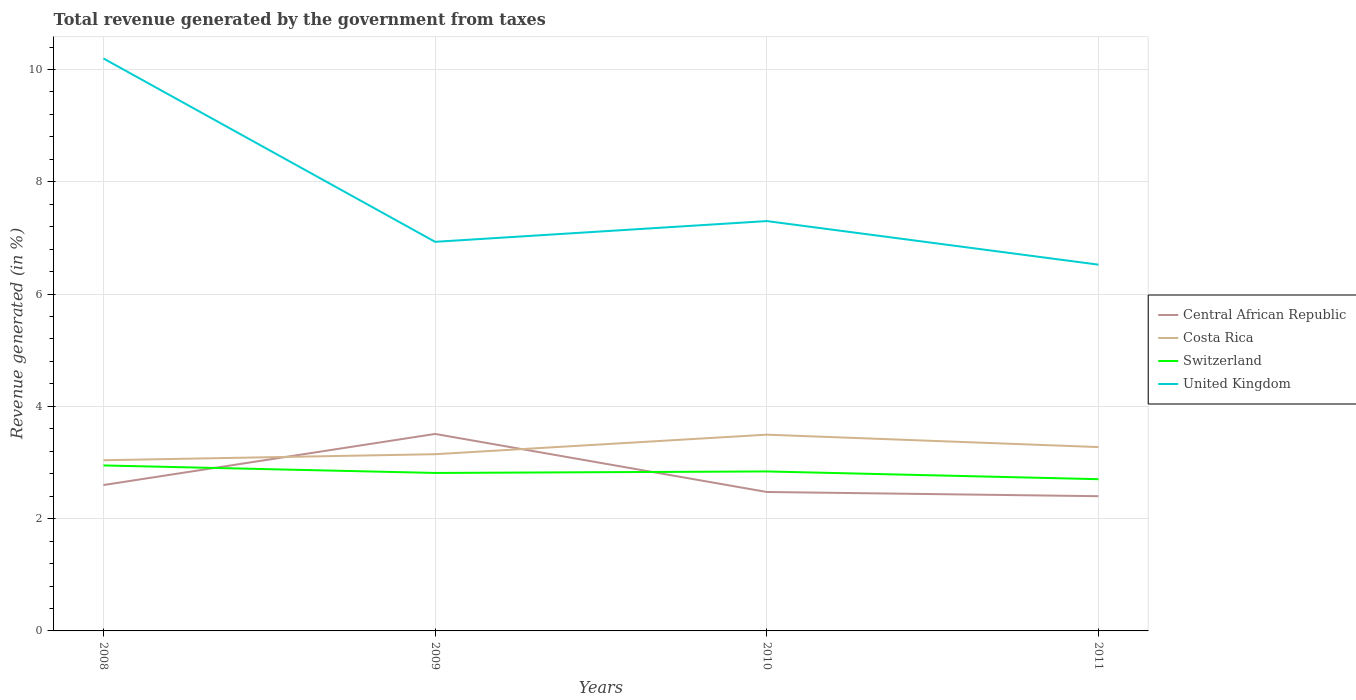Across all years, what is the maximum total revenue generated in United Kingdom?
Ensure brevity in your answer.  6.52. What is the total total revenue generated in Central African Republic in the graph?
Your response must be concise. 0.12. What is the difference between the highest and the second highest total revenue generated in Central African Republic?
Provide a short and direct response. 1.11. Is the total revenue generated in Central African Republic strictly greater than the total revenue generated in Costa Rica over the years?
Give a very brief answer. No. What is the difference between two consecutive major ticks on the Y-axis?
Your answer should be compact. 2. Are the values on the major ticks of Y-axis written in scientific E-notation?
Your answer should be compact. No. Does the graph contain any zero values?
Provide a short and direct response. No. What is the title of the graph?
Offer a terse response. Total revenue generated by the government from taxes. Does "Fiji" appear as one of the legend labels in the graph?
Your answer should be compact. No. What is the label or title of the X-axis?
Provide a short and direct response. Years. What is the label or title of the Y-axis?
Ensure brevity in your answer.  Revenue generated (in %). What is the Revenue generated (in %) in Central African Republic in 2008?
Ensure brevity in your answer.  2.6. What is the Revenue generated (in %) of Costa Rica in 2008?
Ensure brevity in your answer.  3.04. What is the Revenue generated (in %) of Switzerland in 2008?
Your response must be concise. 2.95. What is the Revenue generated (in %) in United Kingdom in 2008?
Ensure brevity in your answer.  10.2. What is the Revenue generated (in %) of Central African Republic in 2009?
Your response must be concise. 3.51. What is the Revenue generated (in %) in Costa Rica in 2009?
Offer a very short reply. 3.15. What is the Revenue generated (in %) of Switzerland in 2009?
Provide a short and direct response. 2.81. What is the Revenue generated (in %) in United Kingdom in 2009?
Provide a succinct answer. 6.93. What is the Revenue generated (in %) in Central African Republic in 2010?
Make the answer very short. 2.47. What is the Revenue generated (in %) of Costa Rica in 2010?
Offer a very short reply. 3.5. What is the Revenue generated (in %) of Switzerland in 2010?
Provide a succinct answer. 2.84. What is the Revenue generated (in %) of United Kingdom in 2010?
Your answer should be very brief. 7.3. What is the Revenue generated (in %) in Central African Republic in 2011?
Make the answer very short. 2.4. What is the Revenue generated (in %) in Costa Rica in 2011?
Offer a very short reply. 3.27. What is the Revenue generated (in %) of Switzerland in 2011?
Your answer should be very brief. 2.7. What is the Revenue generated (in %) in United Kingdom in 2011?
Give a very brief answer. 6.52. Across all years, what is the maximum Revenue generated (in %) in Central African Republic?
Provide a short and direct response. 3.51. Across all years, what is the maximum Revenue generated (in %) in Costa Rica?
Your response must be concise. 3.5. Across all years, what is the maximum Revenue generated (in %) of Switzerland?
Make the answer very short. 2.95. Across all years, what is the maximum Revenue generated (in %) in United Kingdom?
Your response must be concise. 10.2. Across all years, what is the minimum Revenue generated (in %) of Central African Republic?
Offer a terse response. 2.4. Across all years, what is the minimum Revenue generated (in %) in Costa Rica?
Keep it short and to the point. 3.04. Across all years, what is the minimum Revenue generated (in %) of Switzerland?
Ensure brevity in your answer.  2.7. Across all years, what is the minimum Revenue generated (in %) of United Kingdom?
Provide a short and direct response. 6.52. What is the total Revenue generated (in %) of Central African Republic in the graph?
Make the answer very short. 10.98. What is the total Revenue generated (in %) in Costa Rica in the graph?
Your answer should be compact. 12.96. What is the total Revenue generated (in %) of Switzerland in the graph?
Give a very brief answer. 11.31. What is the total Revenue generated (in %) of United Kingdom in the graph?
Provide a short and direct response. 30.95. What is the difference between the Revenue generated (in %) in Central African Republic in 2008 and that in 2009?
Ensure brevity in your answer.  -0.91. What is the difference between the Revenue generated (in %) of Costa Rica in 2008 and that in 2009?
Ensure brevity in your answer.  -0.11. What is the difference between the Revenue generated (in %) of Switzerland in 2008 and that in 2009?
Offer a terse response. 0.13. What is the difference between the Revenue generated (in %) in United Kingdom in 2008 and that in 2009?
Your answer should be very brief. 3.27. What is the difference between the Revenue generated (in %) of Central African Republic in 2008 and that in 2010?
Make the answer very short. 0.12. What is the difference between the Revenue generated (in %) in Costa Rica in 2008 and that in 2010?
Ensure brevity in your answer.  -0.46. What is the difference between the Revenue generated (in %) in Switzerland in 2008 and that in 2010?
Offer a very short reply. 0.11. What is the difference between the Revenue generated (in %) in United Kingdom in 2008 and that in 2010?
Make the answer very short. 2.9. What is the difference between the Revenue generated (in %) in Central African Republic in 2008 and that in 2011?
Ensure brevity in your answer.  0.2. What is the difference between the Revenue generated (in %) in Costa Rica in 2008 and that in 2011?
Your response must be concise. -0.23. What is the difference between the Revenue generated (in %) of Switzerland in 2008 and that in 2011?
Offer a very short reply. 0.24. What is the difference between the Revenue generated (in %) in United Kingdom in 2008 and that in 2011?
Provide a short and direct response. 3.67. What is the difference between the Revenue generated (in %) in Central African Republic in 2009 and that in 2010?
Your answer should be compact. 1.03. What is the difference between the Revenue generated (in %) of Costa Rica in 2009 and that in 2010?
Your answer should be very brief. -0.35. What is the difference between the Revenue generated (in %) of Switzerland in 2009 and that in 2010?
Your response must be concise. -0.03. What is the difference between the Revenue generated (in %) of United Kingdom in 2009 and that in 2010?
Ensure brevity in your answer.  -0.37. What is the difference between the Revenue generated (in %) of Central African Republic in 2009 and that in 2011?
Your response must be concise. 1.11. What is the difference between the Revenue generated (in %) in Costa Rica in 2009 and that in 2011?
Keep it short and to the point. -0.13. What is the difference between the Revenue generated (in %) in United Kingdom in 2009 and that in 2011?
Your answer should be compact. 0.41. What is the difference between the Revenue generated (in %) of Central African Republic in 2010 and that in 2011?
Provide a succinct answer. 0.07. What is the difference between the Revenue generated (in %) in Costa Rica in 2010 and that in 2011?
Provide a succinct answer. 0.22. What is the difference between the Revenue generated (in %) of Switzerland in 2010 and that in 2011?
Make the answer very short. 0.14. What is the difference between the Revenue generated (in %) in United Kingdom in 2010 and that in 2011?
Your answer should be very brief. 0.78. What is the difference between the Revenue generated (in %) of Central African Republic in 2008 and the Revenue generated (in %) of Costa Rica in 2009?
Offer a terse response. -0.55. What is the difference between the Revenue generated (in %) of Central African Republic in 2008 and the Revenue generated (in %) of Switzerland in 2009?
Provide a short and direct response. -0.22. What is the difference between the Revenue generated (in %) in Central African Republic in 2008 and the Revenue generated (in %) in United Kingdom in 2009?
Your answer should be very brief. -4.33. What is the difference between the Revenue generated (in %) in Costa Rica in 2008 and the Revenue generated (in %) in Switzerland in 2009?
Provide a succinct answer. 0.23. What is the difference between the Revenue generated (in %) of Costa Rica in 2008 and the Revenue generated (in %) of United Kingdom in 2009?
Keep it short and to the point. -3.89. What is the difference between the Revenue generated (in %) of Switzerland in 2008 and the Revenue generated (in %) of United Kingdom in 2009?
Make the answer very short. -3.98. What is the difference between the Revenue generated (in %) in Central African Republic in 2008 and the Revenue generated (in %) in Costa Rica in 2010?
Provide a succinct answer. -0.9. What is the difference between the Revenue generated (in %) of Central African Republic in 2008 and the Revenue generated (in %) of Switzerland in 2010?
Your answer should be very brief. -0.24. What is the difference between the Revenue generated (in %) in Central African Republic in 2008 and the Revenue generated (in %) in United Kingdom in 2010?
Provide a short and direct response. -4.7. What is the difference between the Revenue generated (in %) of Costa Rica in 2008 and the Revenue generated (in %) of Switzerland in 2010?
Provide a succinct answer. 0.2. What is the difference between the Revenue generated (in %) in Costa Rica in 2008 and the Revenue generated (in %) in United Kingdom in 2010?
Your answer should be compact. -4.26. What is the difference between the Revenue generated (in %) in Switzerland in 2008 and the Revenue generated (in %) in United Kingdom in 2010?
Your answer should be compact. -4.35. What is the difference between the Revenue generated (in %) in Central African Republic in 2008 and the Revenue generated (in %) in Costa Rica in 2011?
Provide a short and direct response. -0.68. What is the difference between the Revenue generated (in %) of Central African Republic in 2008 and the Revenue generated (in %) of Switzerland in 2011?
Offer a terse response. -0.1. What is the difference between the Revenue generated (in %) of Central African Republic in 2008 and the Revenue generated (in %) of United Kingdom in 2011?
Offer a terse response. -3.93. What is the difference between the Revenue generated (in %) of Costa Rica in 2008 and the Revenue generated (in %) of Switzerland in 2011?
Keep it short and to the point. 0.34. What is the difference between the Revenue generated (in %) in Costa Rica in 2008 and the Revenue generated (in %) in United Kingdom in 2011?
Provide a succinct answer. -3.48. What is the difference between the Revenue generated (in %) in Switzerland in 2008 and the Revenue generated (in %) in United Kingdom in 2011?
Keep it short and to the point. -3.58. What is the difference between the Revenue generated (in %) of Central African Republic in 2009 and the Revenue generated (in %) of Costa Rica in 2010?
Ensure brevity in your answer.  0.01. What is the difference between the Revenue generated (in %) in Central African Republic in 2009 and the Revenue generated (in %) in Switzerland in 2010?
Offer a very short reply. 0.67. What is the difference between the Revenue generated (in %) of Central African Republic in 2009 and the Revenue generated (in %) of United Kingdom in 2010?
Your answer should be compact. -3.79. What is the difference between the Revenue generated (in %) in Costa Rica in 2009 and the Revenue generated (in %) in Switzerland in 2010?
Keep it short and to the point. 0.31. What is the difference between the Revenue generated (in %) in Costa Rica in 2009 and the Revenue generated (in %) in United Kingdom in 2010?
Your response must be concise. -4.15. What is the difference between the Revenue generated (in %) in Switzerland in 2009 and the Revenue generated (in %) in United Kingdom in 2010?
Provide a short and direct response. -4.49. What is the difference between the Revenue generated (in %) of Central African Republic in 2009 and the Revenue generated (in %) of Costa Rica in 2011?
Your answer should be very brief. 0.23. What is the difference between the Revenue generated (in %) in Central African Republic in 2009 and the Revenue generated (in %) in Switzerland in 2011?
Make the answer very short. 0.81. What is the difference between the Revenue generated (in %) of Central African Republic in 2009 and the Revenue generated (in %) of United Kingdom in 2011?
Your answer should be very brief. -3.02. What is the difference between the Revenue generated (in %) of Costa Rica in 2009 and the Revenue generated (in %) of Switzerland in 2011?
Your answer should be very brief. 0.44. What is the difference between the Revenue generated (in %) of Costa Rica in 2009 and the Revenue generated (in %) of United Kingdom in 2011?
Ensure brevity in your answer.  -3.38. What is the difference between the Revenue generated (in %) in Switzerland in 2009 and the Revenue generated (in %) in United Kingdom in 2011?
Ensure brevity in your answer.  -3.71. What is the difference between the Revenue generated (in %) of Central African Republic in 2010 and the Revenue generated (in %) of Costa Rica in 2011?
Provide a short and direct response. -0.8. What is the difference between the Revenue generated (in %) in Central African Republic in 2010 and the Revenue generated (in %) in Switzerland in 2011?
Keep it short and to the point. -0.23. What is the difference between the Revenue generated (in %) of Central African Republic in 2010 and the Revenue generated (in %) of United Kingdom in 2011?
Give a very brief answer. -4.05. What is the difference between the Revenue generated (in %) of Costa Rica in 2010 and the Revenue generated (in %) of Switzerland in 2011?
Your answer should be compact. 0.79. What is the difference between the Revenue generated (in %) of Costa Rica in 2010 and the Revenue generated (in %) of United Kingdom in 2011?
Offer a terse response. -3.03. What is the difference between the Revenue generated (in %) of Switzerland in 2010 and the Revenue generated (in %) of United Kingdom in 2011?
Offer a terse response. -3.68. What is the average Revenue generated (in %) in Central African Republic per year?
Offer a very short reply. 2.75. What is the average Revenue generated (in %) in Costa Rica per year?
Make the answer very short. 3.24. What is the average Revenue generated (in %) in Switzerland per year?
Ensure brevity in your answer.  2.83. What is the average Revenue generated (in %) of United Kingdom per year?
Your answer should be very brief. 7.74. In the year 2008, what is the difference between the Revenue generated (in %) of Central African Republic and Revenue generated (in %) of Costa Rica?
Offer a terse response. -0.44. In the year 2008, what is the difference between the Revenue generated (in %) of Central African Republic and Revenue generated (in %) of Switzerland?
Provide a succinct answer. -0.35. In the year 2008, what is the difference between the Revenue generated (in %) of Central African Republic and Revenue generated (in %) of United Kingdom?
Your answer should be compact. -7.6. In the year 2008, what is the difference between the Revenue generated (in %) of Costa Rica and Revenue generated (in %) of Switzerland?
Ensure brevity in your answer.  0.09. In the year 2008, what is the difference between the Revenue generated (in %) in Costa Rica and Revenue generated (in %) in United Kingdom?
Give a very brief answer. -7.16. In the year 2008, what is the difference between the Revenue generated (in %) of Switzerland and Revenue generated (in %) of United Kingdom?
Ensure brevity in your answer.  -7.25. In the year 2009, what is the difference between the Revenue generated (in %) in Central African Republic and Revenue generated (in %) in Costa Rica?
Ensure brevity in your answer.  0.36. In the year 2009, what is the difference between the Revenue generated (in %) in Central African Republic and Revenue generated (in %) in Switzerland?
Offer a very short reply. 0.69. In the year 2009, what is the difference between the Revenue generated (in %) in Central African Republic and Revenue generated (in %) in United Kingdom?
Provide a short and direct response. -3.42. In the year 2009, what is the difference between the Revenue generated (in %) of Costa Rica and Revenue generated (in %) of Switzerland?
Offer a very short reply. 0.33. In the year 2009, what is the difference between the Revenue generated (in %) of Costa Rica and Revenue generated (in %) of United Kingdom?
Your answer should be compact. -3.78. In the year 2009, what is the difference between the Revenue generated (in %) in Switzerland and Revenue generated (in %) in United Kingdom?
Your response must be concise. -4.12. In the year 2010, what is the difference between the Revenue generated (in %) in Central African Republic and Revenue generated (in %) in Costa Rica?
Offer a terse response. -1.02. In the year 2010, what is the difference between the Revenue generated (in %) in Central African Republic and Revenue generated (in %) in Switzerland?
Make the answer very short. -0.37. In the year 2010, what is the difference between the Revenue generated (in %) of Central African Republic and Revenue generated (in %) of United Kingdom?
Your answer should be very brief. -4.83. In the year 2010, what is the difference between the Revenue generated (in %) in Costa Rica and Revenue generated (in %) in Switzerland?
Make the answer very short. 0.66. In the year 2010, what is the difference between the Revenue generated (in %) of Costa Rica and Revenue generated (in %) of United Kingdom?
Provide a succinct answer. -3.8. In the year 2010, what is the difference between the Revenue generated (in %) in Switzerland and Revenue generated (in %) in United Kingdom?
Offer a terse response. -4.46. In the year 2011, what is the difference between the Revenue generated (in %) of Central African Republic and Revenue generated (in %) of Costa Rica?
Make the answer very short. -0.87. In the year 2011, what is the difference between the Revenue generated (in %) of Central African Republic and Revenue generated (in %) of Switzerland?
Your response must be concise. -0.3. In the year 2011, what is the difference between the Revenue generated (in %) of Central African Republic and Revenue generated (in %) of United Kingdom?
Give a very brief answer. -4.12. In the year 2011, what is the difference between the Revenue generated (in %) in Costa Rica and Revenue generated (in %) in Switzerland?
Offer a very short reply. 0.57. In the year 2011, what is the difference between the Revenue generated (in %) of Costa Rica and Revenue generated (in %) of United Kingdom?
Keep it short and to the point. -3.25. In the year 2011, what is the difference between the Revenue generated (in %) of Switzerland and Revenue generated (in %) of United Kingdom?
Your answer should be very brief. -3.82. What is the ratio of the Revenue generated (in %) in Central African Republic in 2008 to that in 2009?
Ensure brevity in your answer.  0.74. What is the ratio of the Revenue generated (in %) in Costa Rica in 2008 to that in 2009?
Your answer should be compact. 0.97. What is the ratio of the Revenue generated (in %) in Switzerland in 2008 to that in 2009?
Ensure brevity in your answer.  1.05. What is the ratio of the Revenue generated (in %) in United Kingdom in 2008 to that in 2009?
Your answer should be compact. 1.47. What is the ratio of the Revenue generated (in %) of Central African Republic in 2008 to that in 2010?
Give a very brief answer. 1.05. What is the ratio of the Revenue generated (in %) in Costa Rica in 2008 to that in 2010?
Your response must be concise. 0.87. What is the ratio of the Revenue generated (in %) in Switzerland in 2008 to that in 2010?
Offer a terse response. 1.04. What is the ratio of the Revenue generated (in %) of United Kingdom in 2008 to that in 2010?
Offer a terse response. 1.4. What is the ratio of the Revenue generated (in %) in Central African Republic in 2008 to that in 2011?
Offer a very short reply. 1.08. What is the ratio of the Revenue generated (in %) of Costa Rica in 2008 to that in 2011?
Keep it short and to the point. 0.93. What is the ratio of the Revenue generated (in %) of Switzerland in 2008 to that in 2011?
Ensure brevity in your answer.  1.09. What is the ratio of the Revenue generated (in %) of United Kingdom in 2008 to that in 2011?
Provide a succinct answer. 1.56. What is the ratio of the Revenue generated (in %) in Central African Republic in 2009 to that in 2010?
Provide a succinct answer. 1.42. What is the ratio of the Revenue generated (in %) of Costa Rica in 2009 to that in 2010?
Your answer should be very brief. 0.9. What is the ratio of the Revenue generated (in %) of United Kingdom in 2009 to that in 2010?
Provide a short and direct response. 0.95. What is the ratio of the Revenue generated (in %) in Central African Republic in 2009 to that in 2011?
Your answer should be very brief. 1.46. What is the ratio of the Revenue generated (in %) of Costa Rica in 2009 to that in 2011?
Your response must be concise. 0.96. What is the ratio of the Revenue generated (in %) in Switzerland in 2009 to that in 2011?
Keep it short and to the point. 1.04. What is the ratio of the Revenue generated (in %) of United Kingdom in 2009 to that in 2011?
Provide a succinct answer. 1.06. What is the ratio of the Revenue generated (in %) of Central African Republic in 2010 to that in 2011?
Your response must be concise. 1.03. What is the ratio of the Revenue generated (in %) in Costa Rica in 2010 to that in 2011?
Your answer should be compact. 1.07. What is the ratio of the Revenue generated (in %) of Switzerland in 2010 to that in 2011?
Your response must be concise. 1.05. What is the ratio of the Revenue generated (in %) of United Kingdom in 2010 to that in 2011?
Give a very brief answer. 1.12. What is the difference between the highest and the second highest Revenue generated (in %) of Central African Republic?
Provide a short and direct response. 0.91. What is the difference between the highest and the second highest Revenue generated (in %) in Costa Rica?
Offer a terse response. 0.22. What is the difference between the highest and the second highest Revenue generated (in %) of Switzerland?
Provide a succinct answer. 0.11. What is the difference between the highest and the second highest Revenue generated (in %) in United Kingdom?
Offer a very short reply. 2.9. What is the difference between the highest and the lowest Revenue generated (in %) of Central African Republic?
Provide a succinct answer. 1.11. What is the difference between the highest and the lowest Revenue generated (in %) of Costa Rica?
Your answer should be very brief. 0.46. What is the difference between the highest and the lowest Revenue generated (in %) of Switzerland?
Ensure brevity in your answer.  0.24. What is the difference between the highest and the lowest Revenue generated (in %) in United Kingdom?
Offer a very short reply. 3.67. 